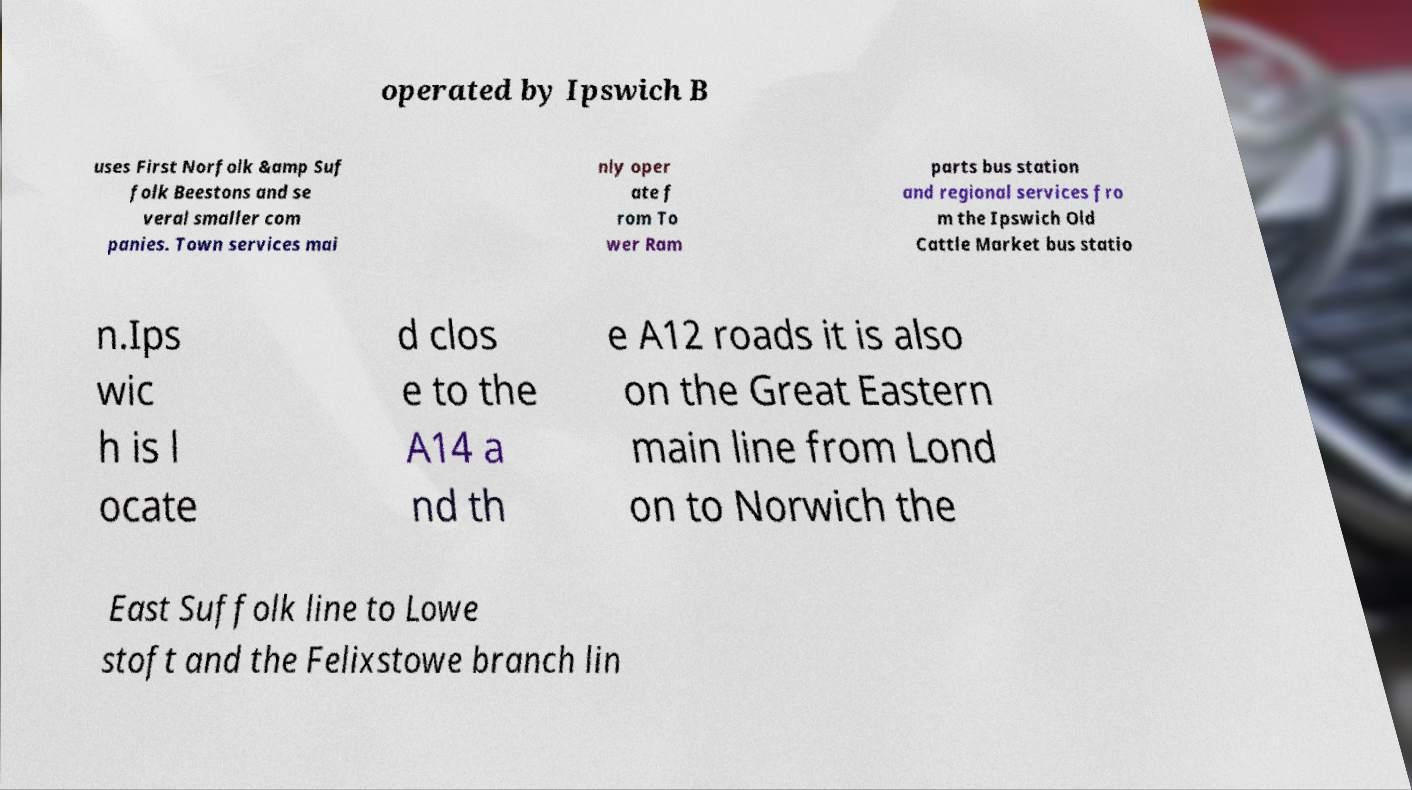Please read and relay the text visible in this image. What does it say? operated by Ipswich B uses First Norfolk &amp Suf folk Beestons and se veral smaller com panies. Town services mai nly oper ate f rom To wer Ram parts bus station and regional services fro m the Ipswich Old Cattle Market bus statio n.Ips wic h is l ocate d clos e to the A14 a nd th e A12 roads it is also on the Great Eastern main line from Lond on to Norwich the East Suffolk line to Lowe stoft and the Felixstowe branch lin 